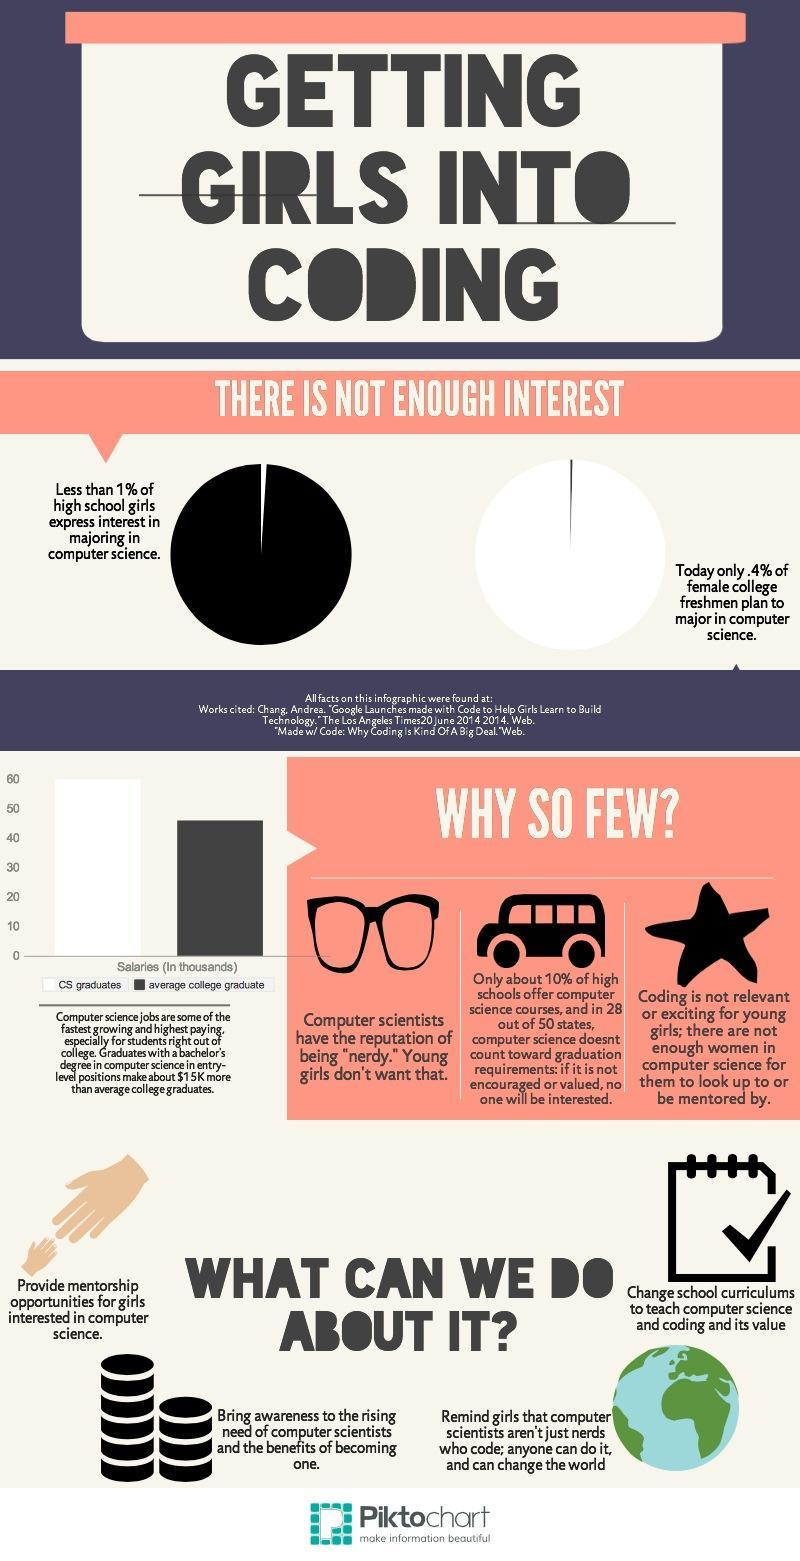What percentage of high schools are not offering computer science courses?
Answer the question with a short phrase. 90% Out of 50, how many states count computer science towards graduation requirements? 22 